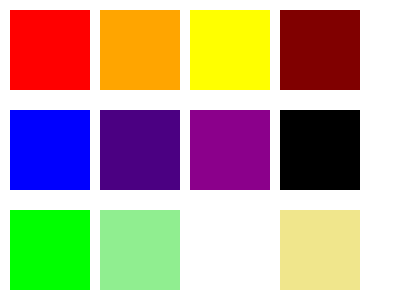Which row of color palettes would be most suitable for a production of Anton Chekhov's "The Cherry Orchard," considering the play's themes of change, loss, and nostalgia? To answer this question, we need to consider the themes and mood of Chekhov's "The Cherry Orchard" and match them with the appropriate color palette:

1. The first row (red, orange, yellow, maroon) represents warm, vibrant colors. These suggest energy, passion, and intensity, which don't align well with the play's melancholic tone.

2. The second row (blue, indigo, purple, black) consists of cool, deep colors. These colors evoke feelings of sadness, introspection, and depth, which closely match the play's themes of loss and nostalgia.

3. The third row (green, light green, white, khaki) features lighter, more natural tones. While these could represent the cherry orchard itself, they don't fully capture the emotional weight of the play.

Considering the play's themes:
- Change: The deep blues and purples in the second row can represent the transition from old to new.
- Loss: The darker tones, especially the black, symbolize the loss experienced by the characters.
- Nostalgia: The rich indigo and purple hues evoke a sense of longing for the past.

Therefore, the second row of colors would be most appropriate for a production of "The Cherry Orchard," as it best captures the play's emotional landscape and thematic elements.
Answer: Second row (blue, indigo, purple, black) 